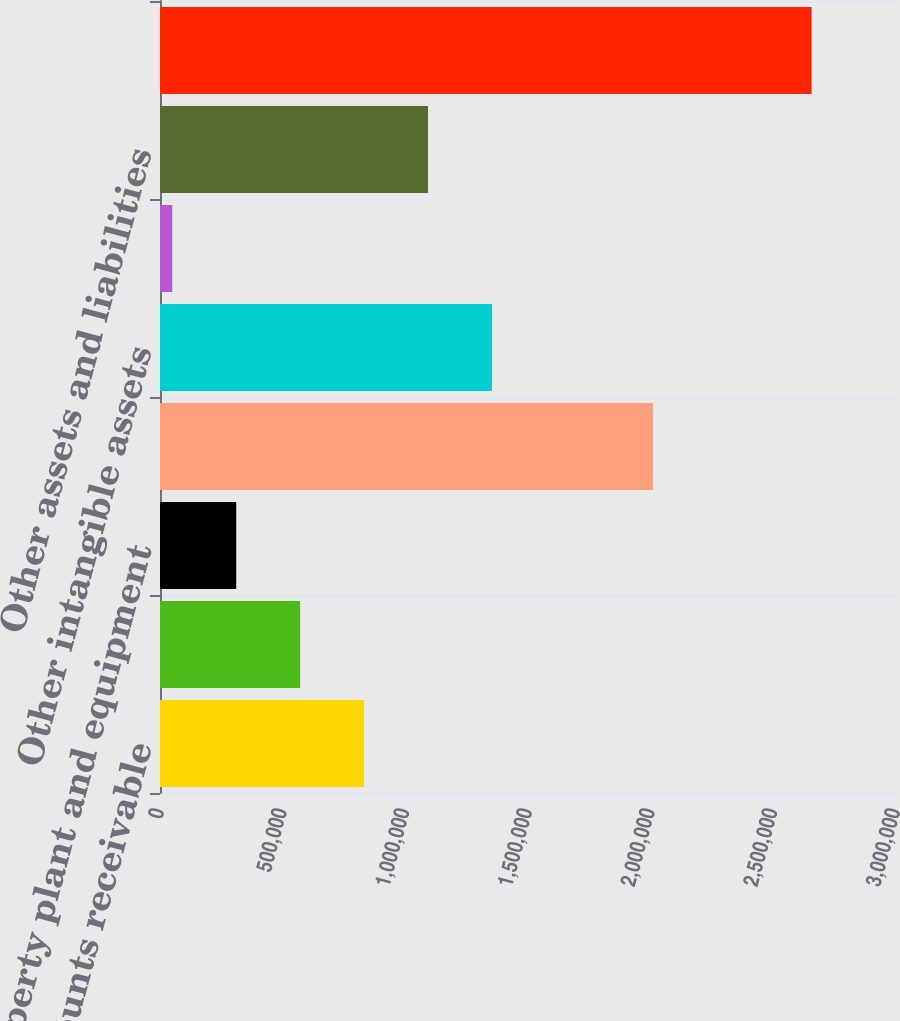Convert chart to OTSL. <chart><loc_0><loc_0><loc_500><loc_500><bar_chart><fcel>Accounts receivable<fcel>Inventory<fcel>Property plant and equipment<fcel>Goodwill<fcel>Other intangible assets<fcel>Accounts payable<fcel>Other assets and liabilities<fcel>Net cash consideration<nl><fcel>831850<fcel>571253<fcel>310655<fcel>2.00983e+06<fcel>1.35305e+06<fcel>50057<fcel>1.09245e+06<fcel>2.65604e+06<nl></chart> 